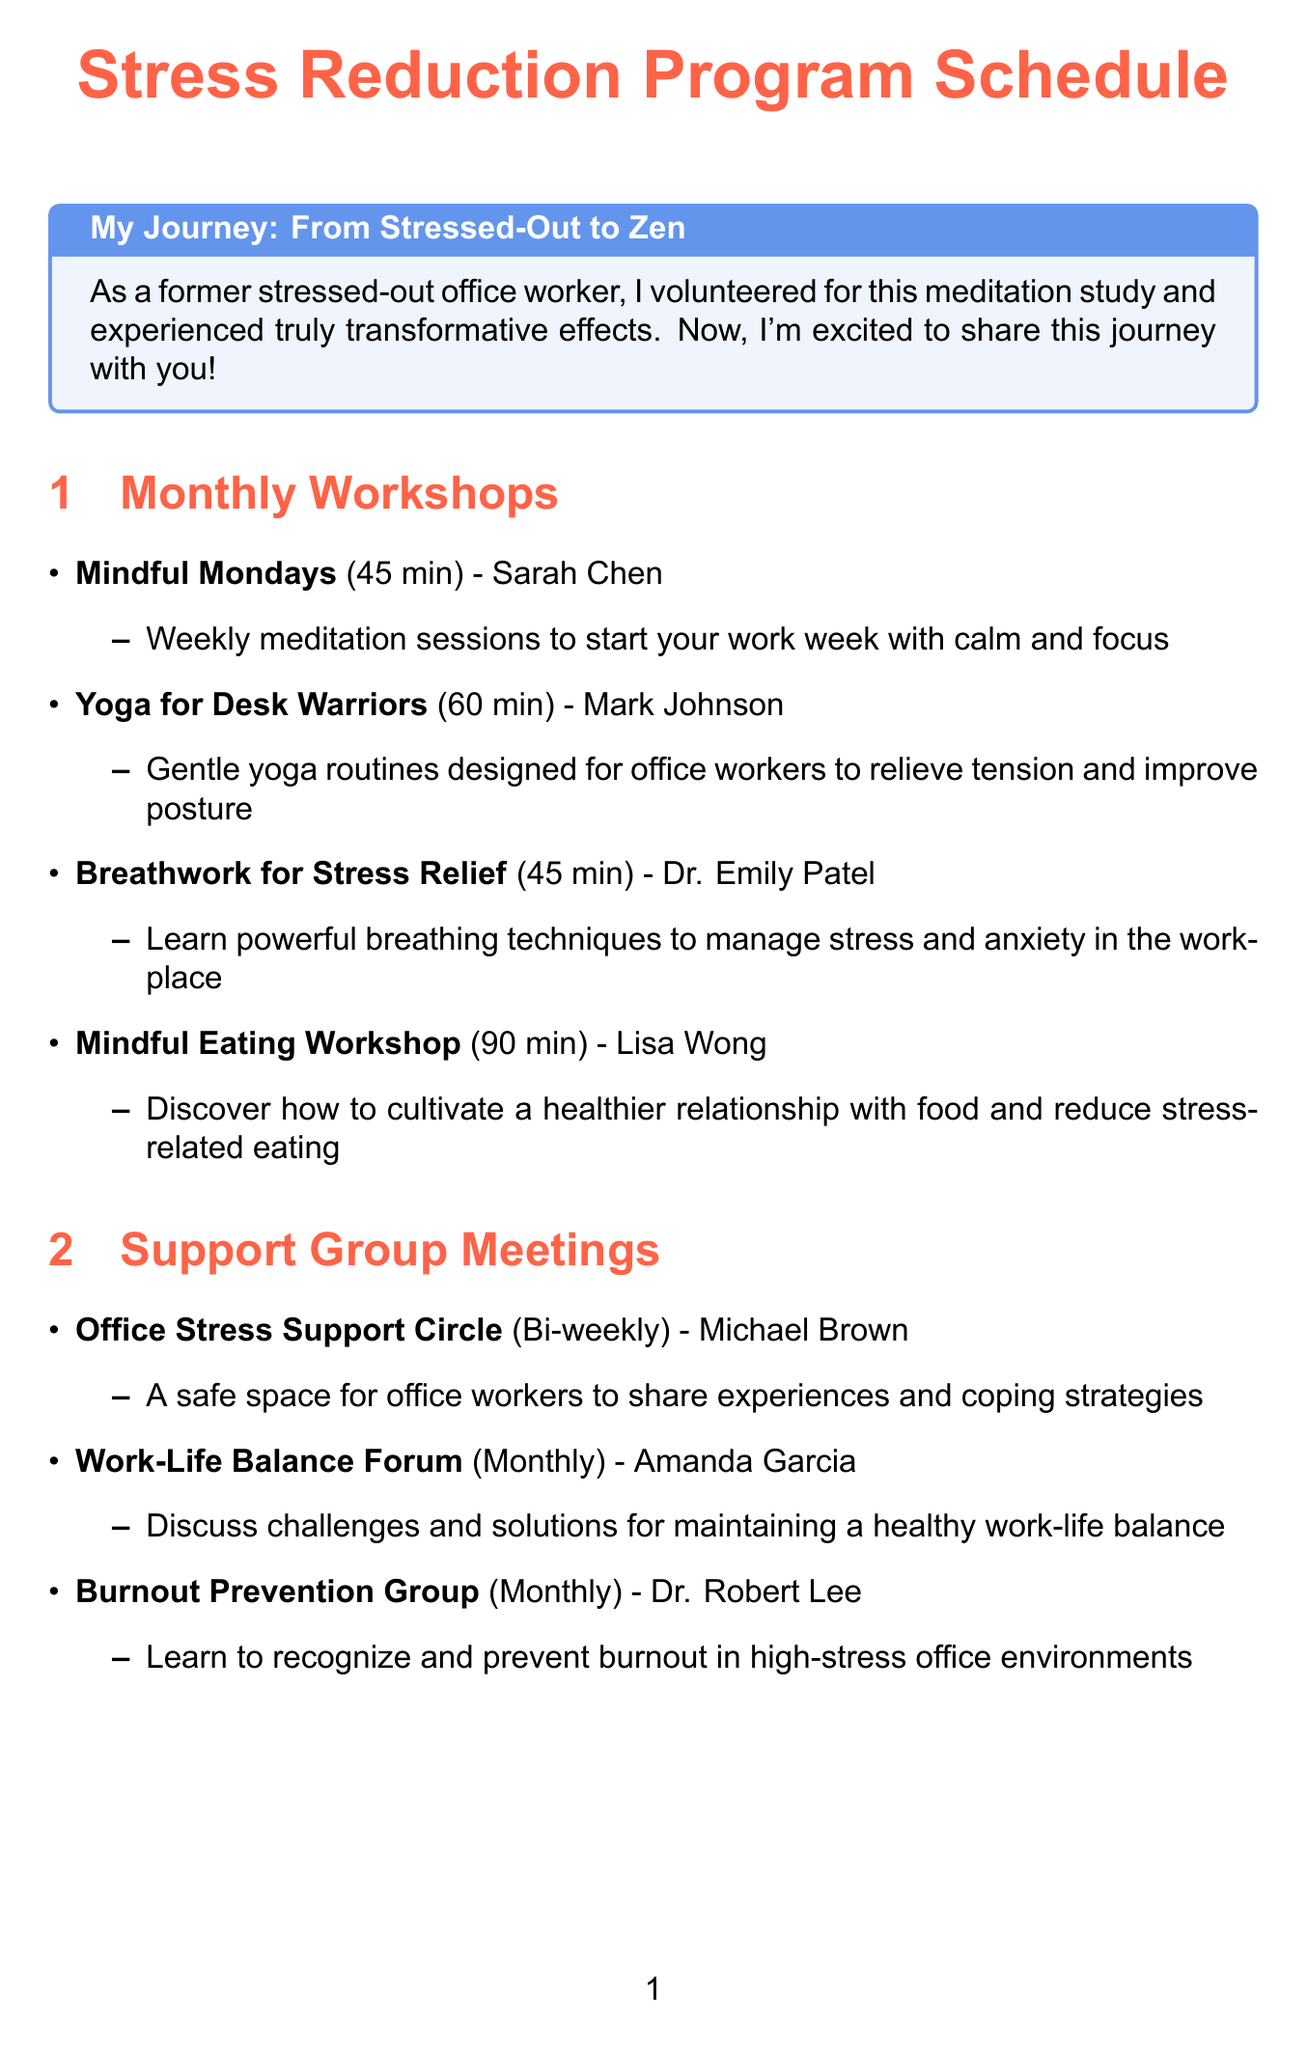What is the name of the monthly workshop that focuses on meditation? The name of the workshop is specifically mentioned in the document under monthly workshops, which is "Mindful Mondays".
Answer: Mindful Mondays Who is the instructor for the Yoga for Desk Warriors workshop? The instructor's name is provided in the document alongside the workshop description, which is Mark Johnson.
Answer: Mark Johnson How long does the Mindful Eating Workshop last? The duration of the workshop is stated in parentheses next to the workshop name and is 90 minutes.
Answer: 90 minutes How often does the Office Stress Support Circle meet? The frequency for this support group meeting is noted in the document, which states it is bi-weekly.
Answer: Bi-weekly What is included in the Stress-Relief Care Package? The document describes the contents of this package as monthly deliveries of items like herbal teas and aromatherapy candles.
Answer: Stress-relief items like herbal teas, aromatherapy candles, and stress balls Which workshop focuses on breathing techniques? The document specifies the workshop that teaches breathing techniques, which is titled "Breathwork for Stress Relief".
Answer: Breathwork for Stress Relief Who facilitates the Work-Life Balance Forum? The facilitator's name is listed in the document next to the forum description, which is Amanda Garcia.
Answer: Amanda Garcia What is the duration of the Breathwork for Stress Relief workshop? The duration is indicated clearly next to the workshop title in the document, which is 45 minutes.
Answer: 45 minutes 